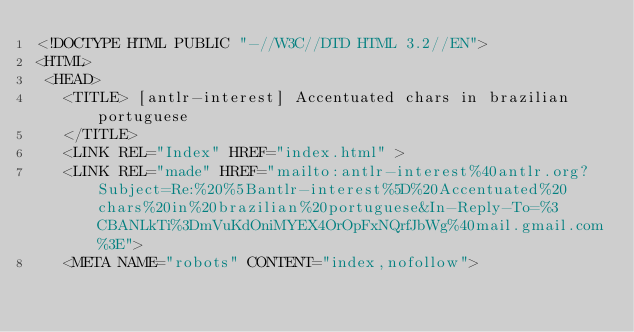Convert code to text. <code><loc_0><loc_0><loc_500><loc_500><_HTML_><!DOCTYPE HTML PUBLIC "-//W3C//DTD HTML 3.2//EN">
<HTML>
 <HEAD>
   <TITLE> [antlr-interest] Accentuated chars in brazilian portuguese
   </TITLE>
   <LINK REL="Index" HREF="index.html" >
   <LINK REL="made" HREF="mailto:antlr-interest%40antlr.org?Subject=Re:%20%5Bantlr-interest%5D%20Accentuated%20chars%20in%20brazilian%20portuguese&In-Reply-To=%3CBANLkTi%3DmVuKdOniMYEX4OrOpFxNQrfJbWg%40mail.gmail.com%3E">
   <META NAME="robots" CONTENT="index,nofollow"></code> 